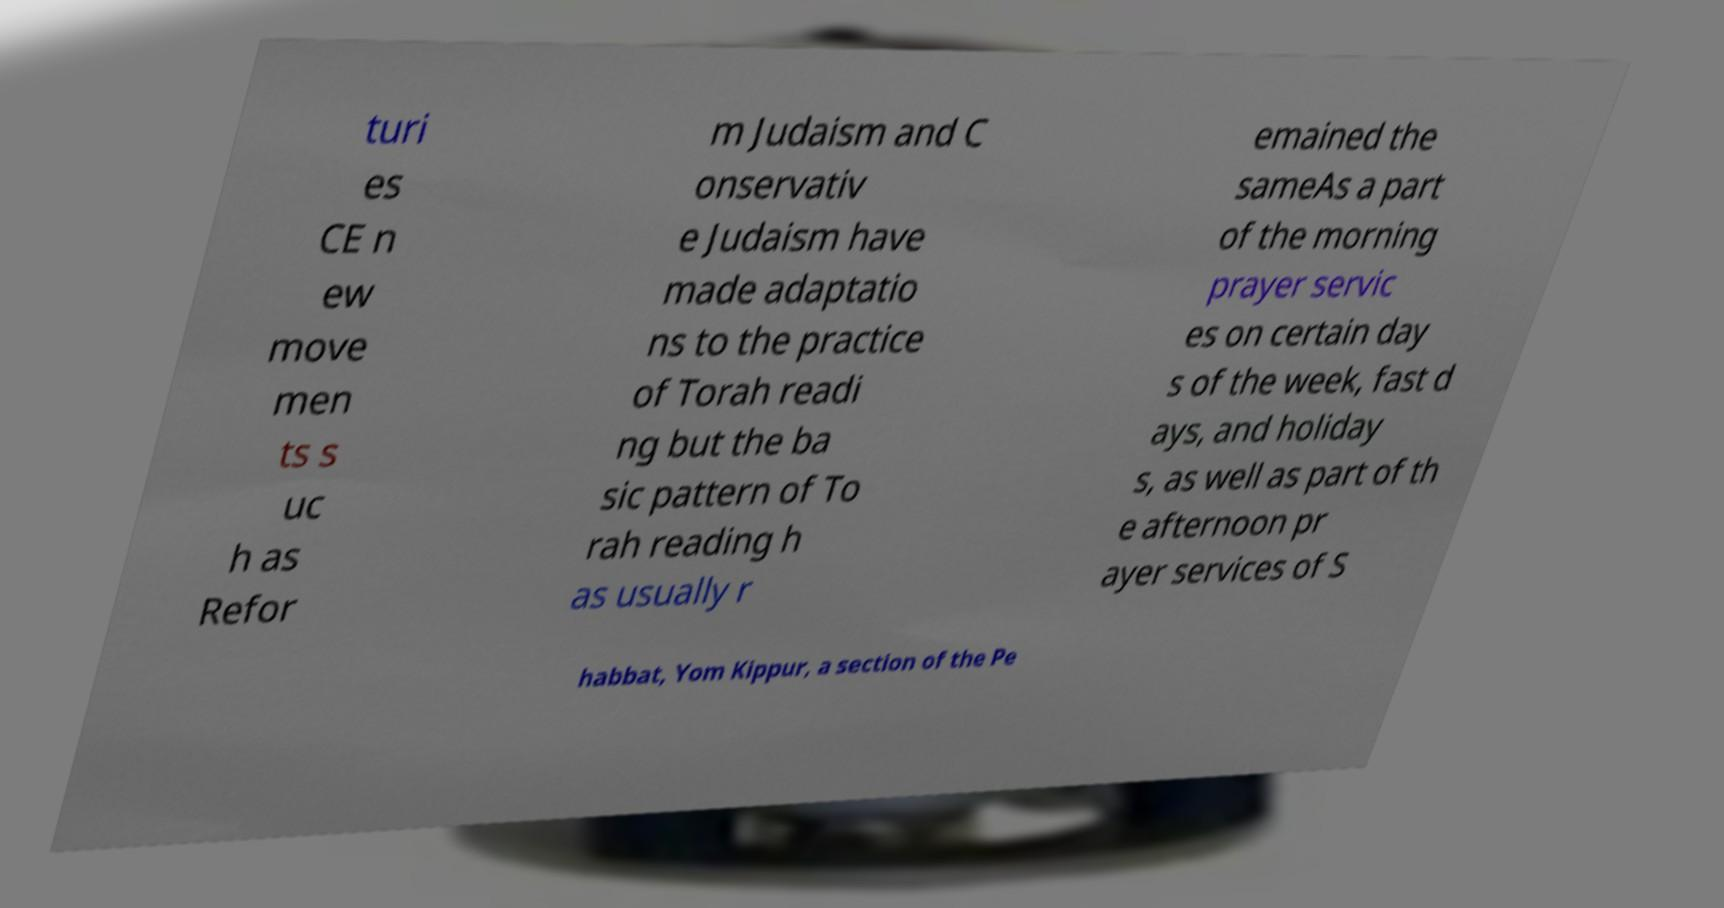Could you assist in decoding the text presented in this image and type it out clearly? turi es CE n ew move men ts s uc h as Refor m Judaism and C onservativ e Judaism have made adaptatio ns to the practice of Torah readi ng but the ba sic pattern of To rah reading h as usually r emained the sameAs a part of the morning prayer servic es on certain day s of the week, fast d ays, and holiday s, as well as part of th e afternoon pr ayer services of S habbat, Yom Kippur, a section of the Pe 